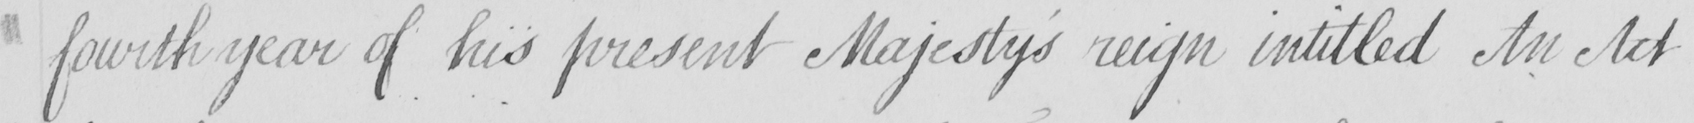Transcribe the text shown in this historical manuscript line. fourth year of his present Majesty ' s reign intitled An Act 